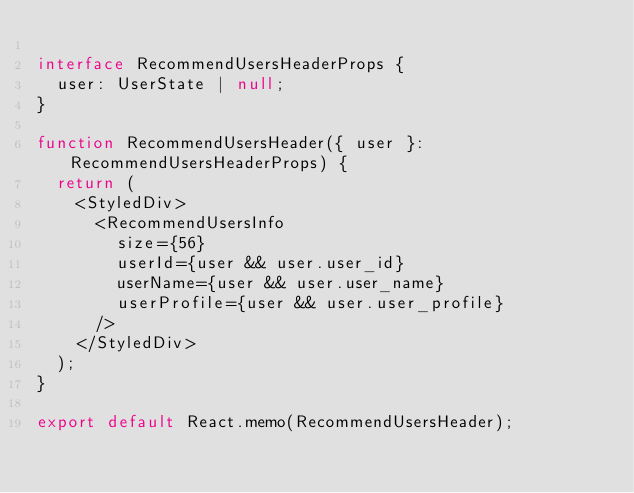Convert code to text. <code><loc_0><loc_0><loc_500><loc_500><_TypeScript_>
interface RecommendUsersHeaderProps {
  user: UserState | null;
}

function RecommendUsersHeader({ user }: RecommendUsersHeaderProps) {
  return (
    <StyledDiv>
      <RecommendUsersInfo
        size={56}
        userId={user && user.user_id}
        userName={user && user.user_name}
        userProfile={user && user.user_profile}
      />
    </StyledDiv>
  );
}

export default React.memo(RecommendUsersHeader);
</code> 